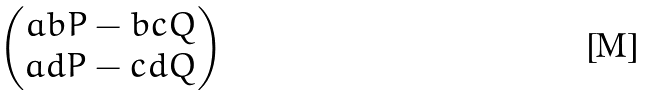<formula> <loc_0><loc_0><loc_500><loc_500>\begin{pmatrix} a b P - b c Q \\ a d P - c d Q \end{pmatrix}</formula> 